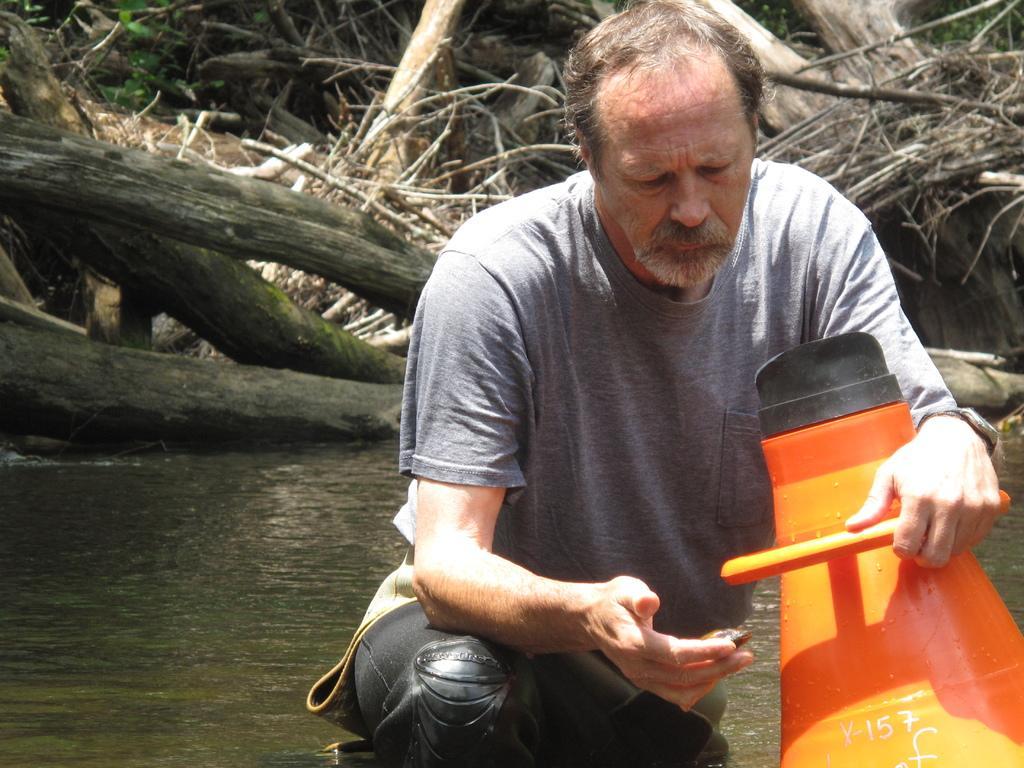In one or two sentences, can you explain what this image depicts? This image consists of a man sitting. At the bottom, there is water. In the background, we can see dry leaves and plants along with the trunks of the trees. It looks like it is clicked in a forest. He is holding an object, which in orange color. 